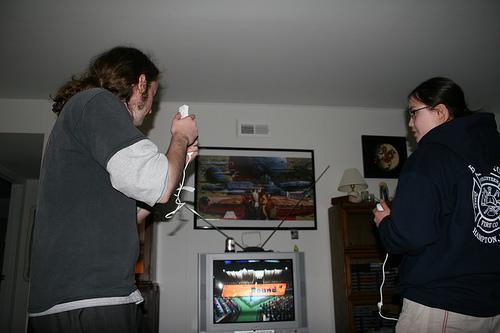How many people in the image?
Give a very brief answer. 2. 